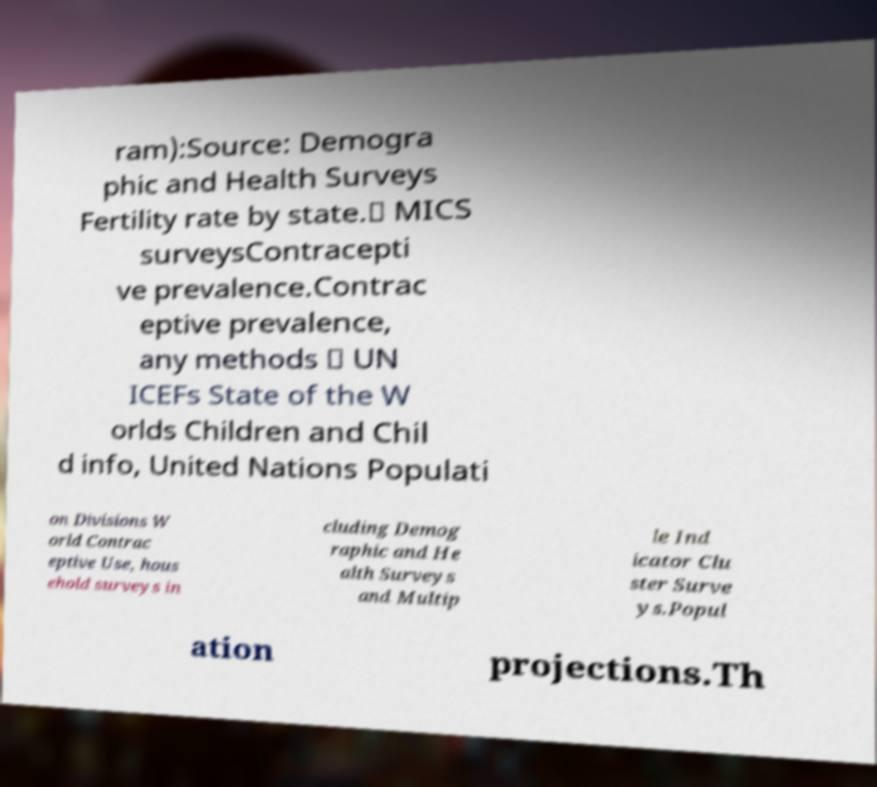I need the written content from this picture converted into text. Can you do that? ram):Source: Demogra phic and Health Surveys Fertility rate by state.∗ MICS surveysContracepti ve prevalence.Contrac eptive prevalence, any methods ∗ UN ICEFs State of the W orlds Children and Chil d info, United Nations Populati on Divisions W orld Contrac eptive Use, hous ehold surveys in cluding Demog raphic and He alth Surveys and Multip le Ind icator Clu ster Surve ys.Popul ation projections.Th 